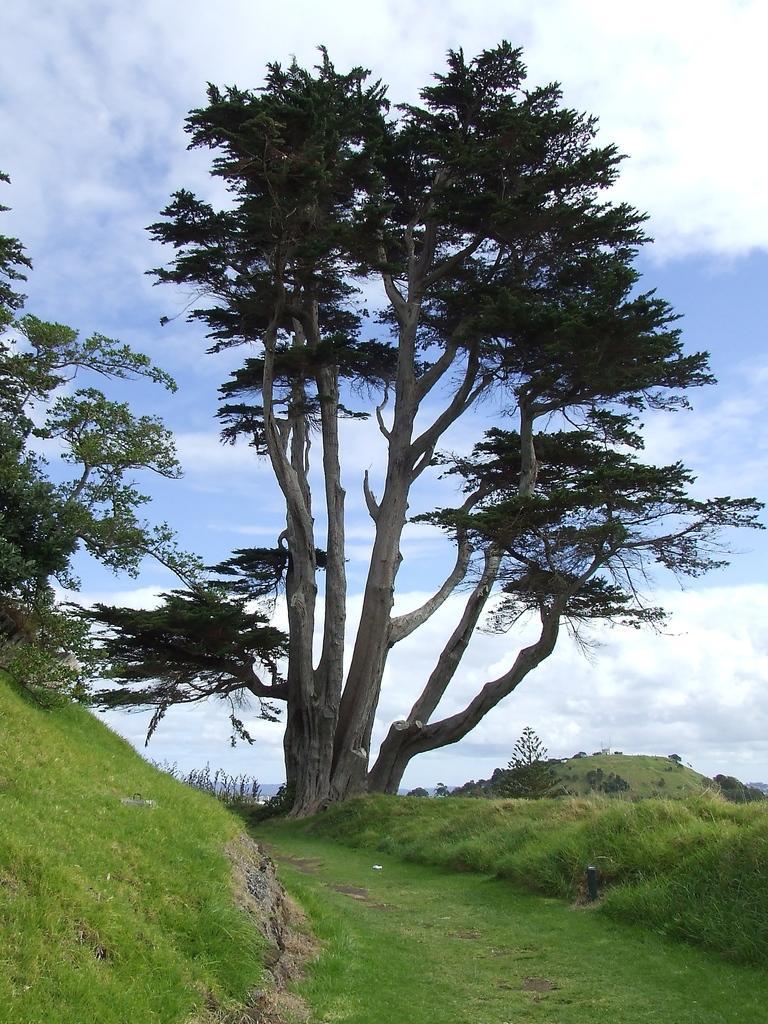In one or two sentences, can you explain what this image depicts? In this picture we can see grass, few trees and clouds. 